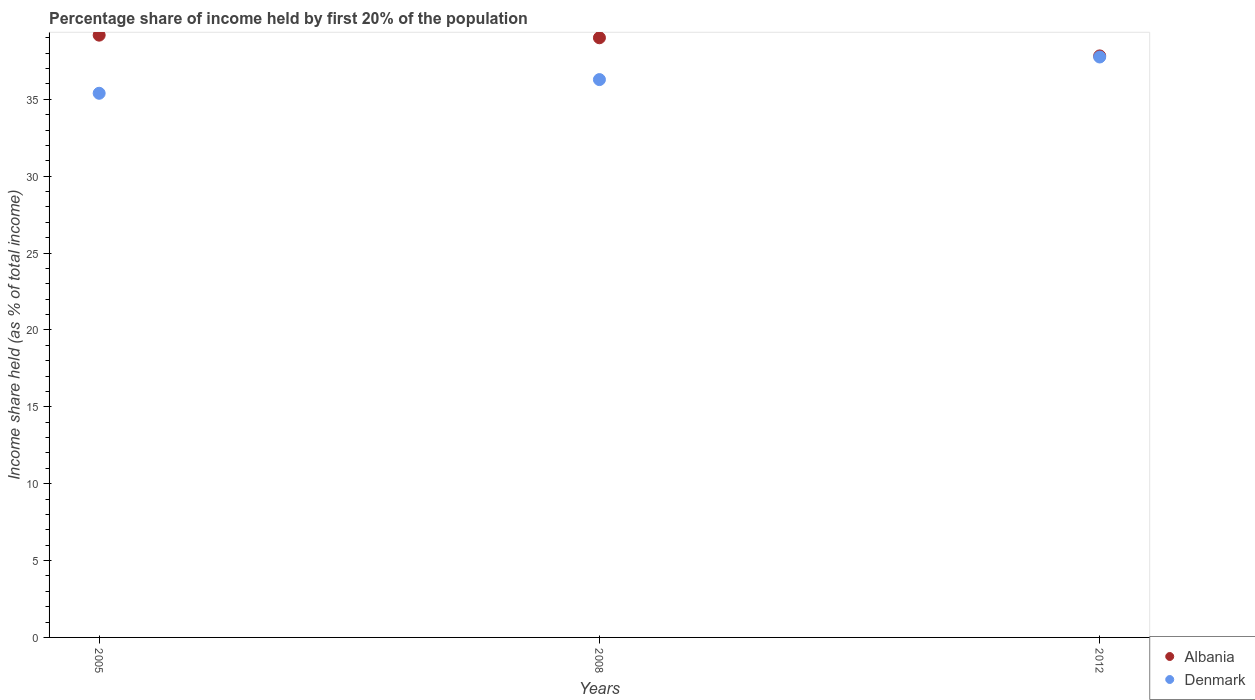Across all years, what is the maximum share of income held by first 20% of the population in Albania?
Offer a terse response. 39.17. Across all years, what is the minimum share of income held by first 20% of the population in Denmark?
Your answer should be compact. 35.39. In which year was the share of income held by first 20% of the population in Denmark maximum?
Offer a terse response. 2012. In which year was the share of income held by first 20% of the population in Albania minimum?
Make the answer very short. 2012. What is the total share of income held by first 20% of the population in Denmark in the graph?
Offer a very short reply. 109.42. What is the difference between the share of income held by first 20% of the population in Albania in 2008 and that in 2012?
Your answer should be compact. 1.18. What is the difference between the share of income held by first 20% of the population in Albania in 2005 and the share of income held by first 20% of the population in Denmark in 2012?
Provide a succinct answer. 1.42. What is the average share of income held by first 20% of the population in Denmark per year?
Make the answer very short. 36.47. In the year 2005, what is the difference between the share of income held by first 20% of the population in Albania and share of income held by first 20% of the population in Denmark?
Your answer should be very brief. 3.78. What is the ratio of the share of income held by first 20% of the population in Denmark in 2008 to that in 2012?
Your response must be concise. 0.96. Is the share of income held by first 20% of the population in Denmark in 2005 less than that in 2008?
Keep it short and to the point. Yes. What is the difference between the highest and the second highest share of income held by first 20% of the population in Denmark?
Give a very brief answer. 1.47. What is the difference between the highest and the lowest share of income held by first 20% of the population in Albania?
Provide a succinct answer. 1.35. Does the share of income held by first 20% of the population in Denmark monotonically increase over the years?
Offer a terse response. Yes. Is the share of income held by first 20% of the population in Albania strictly less than the share of income held by first 20% of the population in Denmark over the years?
Provide a short and direct response. No. Are the values on the major ticks of Y-axis written in scientific E-notation?
Ensure brevity in your answer.  No. Does the graph contain any zero values?
Offer a very short reply. No. Does the graph contain grids?
Give a very brief answer. No. Where does the legend appear in the graph?
Ensure brevity in your answer.  Bottom right. How many legend labels are there?
Keep it short and to the point. 2. How are the legend labels stacked?
Your answer should be compact. Vertical. What is the title of the graph?
Give a very brief answer. Percentage share of income held by first 20% of the population. Does "Caribbean small states" appear as one of the legend labels in the graph?
Provide a short and direct response. No. What is the label or title of the X-axis?
Provide a succinct answer. Years. What is the label or title of the Y-axis?
Your answer should be very brief. Income share held (as % of total income). What is the Income share held (as % of total income) of Albania in 2005?
Provide a short and direct response. 39.17. What is the Income share held (as % of total income) in Denmark in 2005?
Ensure brevity in your answer.  35.39. What is the Income share held (as % of total income) of Denmark in 2008?
Make the answer very short. 36.28. What is the Income share held (as % of total income) of Albania in 2012?
Make the answer very short. 37.82. What is the Income share held (as % of total income) of Denmark in 2012?
Your answer should be very brief. 37.75. Across all years, what is the maximum Income share held (as % of total income) of Albania?
Your response must be concise. 39.17. Across all years, what is the maximum Income share held (as % of total income) in Denmark?
Provide a short and direct response. 37.75. Across all years, what is the minimum Income share held (as % of total income) of Albania?
Provide a succinct answer. 37.82. Across all years, what is the minimum Income share held (as % of total income) of Denmark?
Provide a succinct answer. 35.39. What is the total Income share held (as % of total income) of Albania in the graph?
Provide a short and direct response. 115.99. What is the total Income share held (as % of total income) of Denmark in the graph?
Offer a terse response. 109.42. What is the difference between the Income share held (as % of total income) in Albania in 2005 and that in 2008?
Provide a short and direct response. 0.17. What is the difference between the Income share held (as % of total income) in Denmark in 2005 and that in 2008?
Offer a terse response. -0.89. What is the difference between the Income share held (as % of total income) in Albania in 2005 and that in 2012?
Provide a succinct answer. 1.35. What is the difference between the Income share held (as % of total income) of Denmark in 2005 and that in 2012?
Make the answer very short. -2.36. What is the difference between the Income share held (as % of total income) of Albania in 2008 and that in 2012?
Your response must be concise. 1.18. What is the difference between the Income share held (as % of total income) in Denmark in 2008 and that in 2012?
Make the answer very short. -1.47. What is the difference between the Income share held (as % of total income) in Albania in 2005 and the Income share held (as % of total income) in Denmark in 2008?
Offer a very short reply. 2.89. What is the difference between the Income share held (as % of total income) in Albania in 2005 and the Income share held (as % of total income) in Denmark in 2012?
Give a very brief answer. 1.42. What is the difference between the Income share held (as % of total income) of Albania in 2008 and the Income share held (as % of total income) of Denmark in 2012?
Provide a short and direct response. 1.25. What is the average Income share held (as % of total income) of Albania per year?
Provide a succinct answer. 38.66. What is the average Income share held (as % of total income) in Denmark per year?
Offer a very short reply. 36.47. In the year 2005, what is the difference between the Income share held (as % of total income) of Albania and Income share held (as % of total income) of Denmark?
Your answer should be compact. 3.78. In the year 2008, what is the difference between the Income share held (as % of total income) of Albania and Income share held (as % of total income) of Denmark?
Your answer should be very brief. 2.72. In the year 2012, what is the difference between the Income share held (as % of total income) of Albania and Income share held (as % of total income) of Denmark?
Your answer should be very brief. 0.07. What is the ratio of the Income share held (as % of total income) of Albania in 2005 to that in 2008?
Keep it short and to the point. 1. What is the ratio of the Income share held (as % of total income) in Denmark in 2005 to that in 2008?
Your answer should be compact. 0.98. What is the ratio of the Income share held (as % of total income) of Albania in 2005 to that in 2012?
Your answer should be compact. 1.04. What is the ratio of the Income share held (as % of total income) in Albania in 2008 to that in 2012?
Offer a very short reply. 1.03. What is the ratio of the Income share held (as % of total income) in Denmark in 2008 to that in 2012?
Ensure brevity in your answer.  0.96. What is the difference between the highest and the second highest Income share held (as % of total income) of Albania?
Your answer should be very brief. 0.17. What is the difference between the highest and the second highest Income share held (as % of total income) of Denmark?
Give a very brief answer. 1.47. What is the difference between the highest and the lowest Income share held (as % of total income) of Albania?
Offer a very short reply. 1.35. What is the difference between the highest and the lowest Income share held (as % of total income) of Denmark?
Make the answer very short. 2.36. 